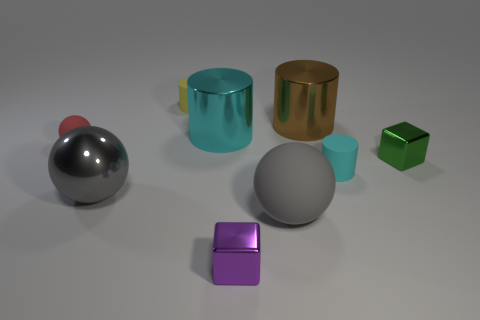What number of other things are there of the same color as the metal ball?
Make the answer very short. 1. There is another large sphere that is the same color as the big shiny ball; what is it made of?
Offer a very short reply. Rubber. Are the big brown cylinder and the cyan object that is in front of the tiny green cube made of the same material?
Your answer should be very brief. No. What number of rubber balls are the same color as the big metal sphere?
Make the answer very short. 1. What number of things are matte objects that are left of the tiny yellow thing or large things?
Provide a succinct answer. 5. Are there any other objects of the same size as the brown object?
Offer a very short reply. Yes. There is a small yellow thing that is behind the red sphere; is there a tiny purple thing that is to the right of it?
Offer a very short reply. Yes. How many balls are either large rubber things or small red things?
Your answer should be very brief. 2. Are there any other things of the same shape as the green shiny thing?
Offer a terse response. Yes. The small green shiny object is what shape?
Ensure brevity in your answer.  Cube. 